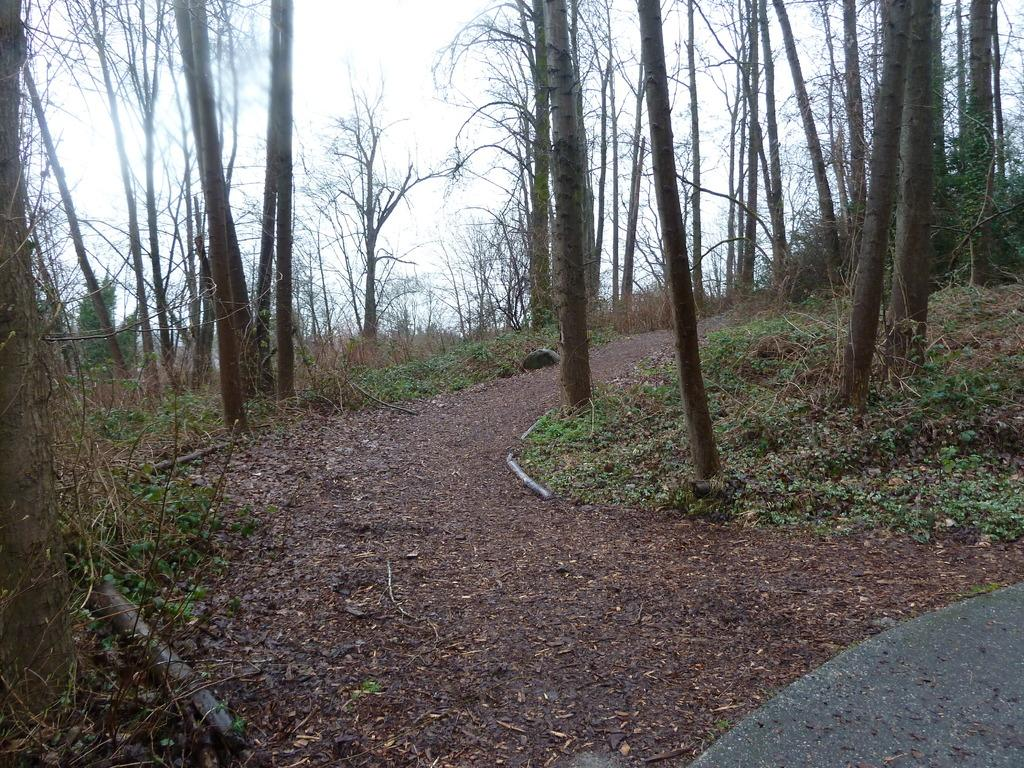What is the main subject in the middle of the image? The trunk of trees is in the middle of the image. What can be seen in the background of the image? There are trees in the background of the image. What type of vegetation is present near the walkway? Small plants are present on the side of the walkway. What color is the orange that is hanging from the tree in the image? There is no orange present in the image; it only features trees and small plants. 